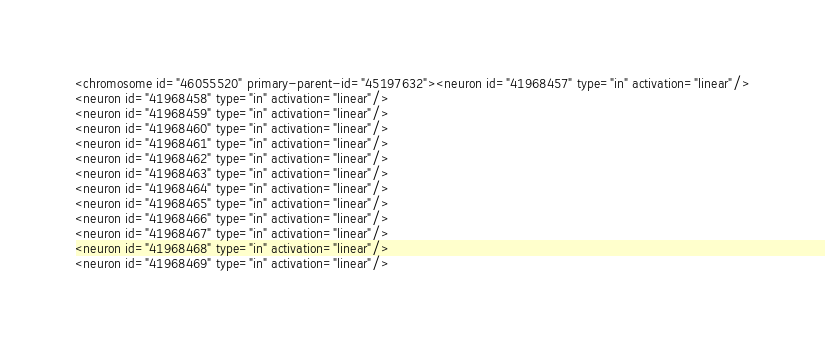Convert code to text. <code><loc_0><loc_0><loc_500><loc_500><_XML_><chromosome id="46055520" primary-parent-id="45197632"><neuron id="41968457" type="in" activation="linear"/>
<neuron id="41968458" type="in" activation="linear"/>
<neuron id="41968459" type="in" activation="linear"/>
<neuron id="41968460" type="in" activation="linear"/>
<neuron id="41968461" type="in" activation="linear"/>
<neuron id="41968462" type="in" activation="linear"/>
<neuron id="41968463" type="in" activation="linear"/>
<neuron id="41968464" type="in" activation="linear"/>
<neuron id="41968465" type="in" activation="linear"/>
<neuron id="41968466" type="in" activation="linear"/>
<neuron id="41968467" type="in" activation="linear"/>
<neuron id="41968468" type="in" activation="linear"/>
<neuron id="41968469" type="in" activation="linear"/></code> 